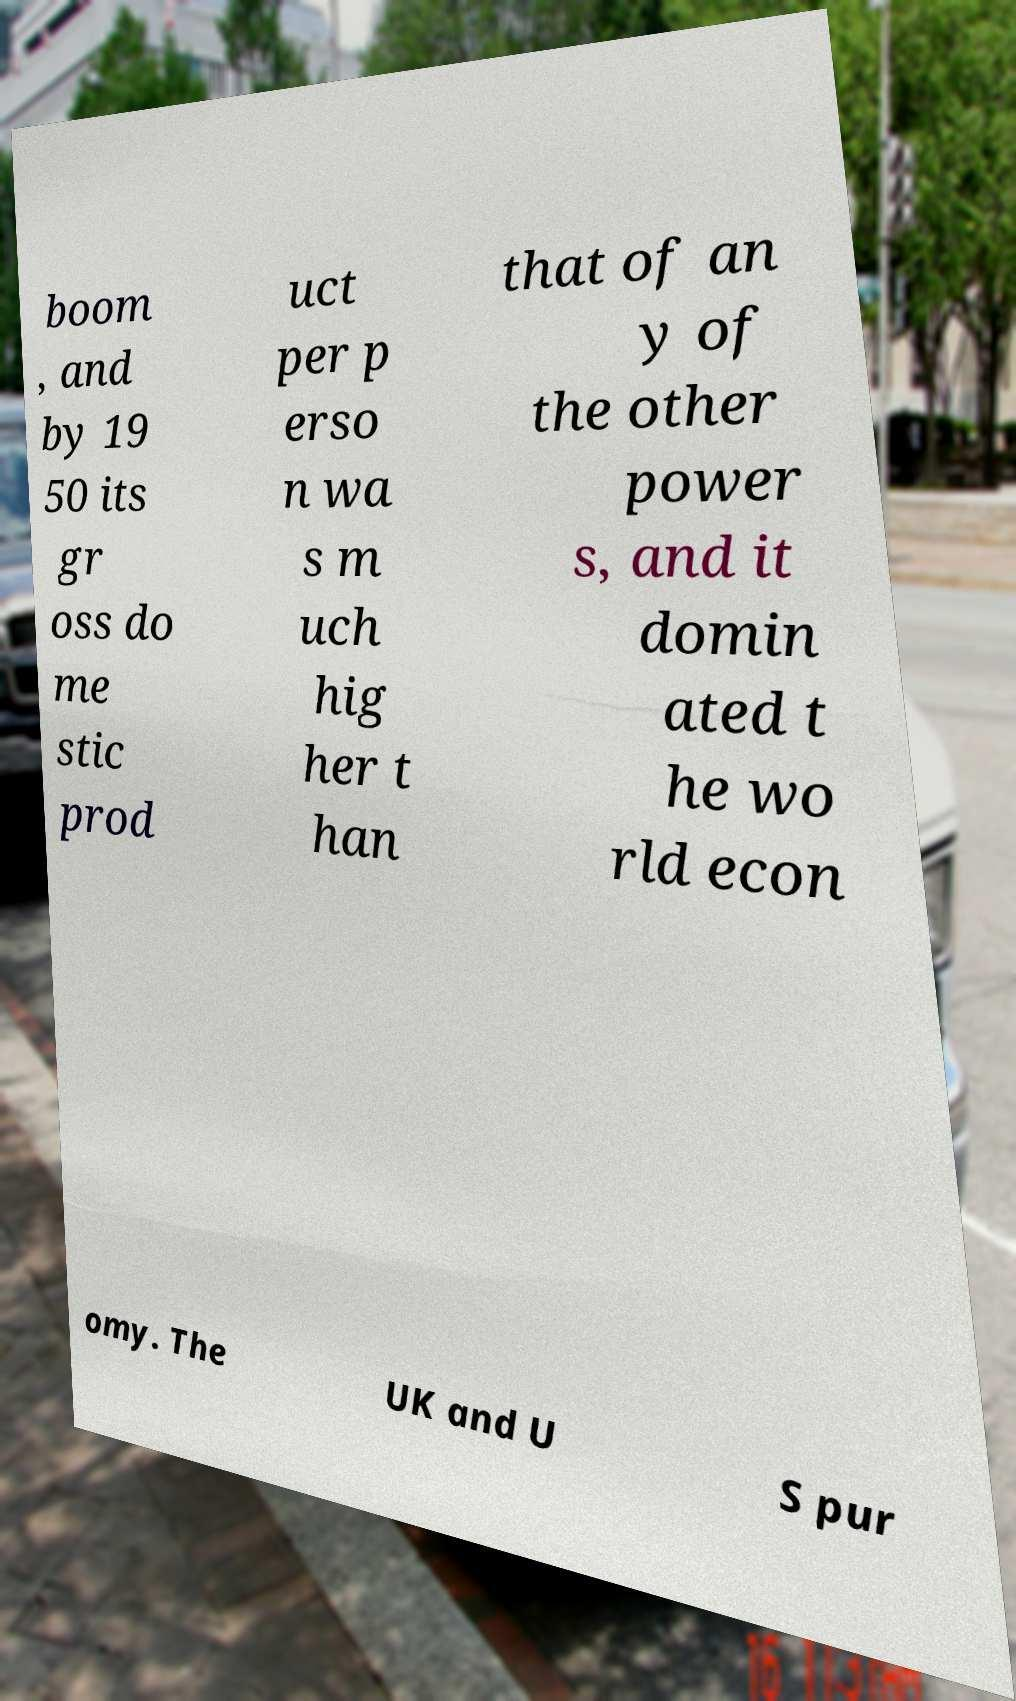Could you extract and type out the text from this image? boom , and by 19 50 its gr oss do me stic prod uct per p erso n wa s m uch hig her t han that of an y of the other power s, and it domin ated t he wo rld econ omy. The UK and U S pur 